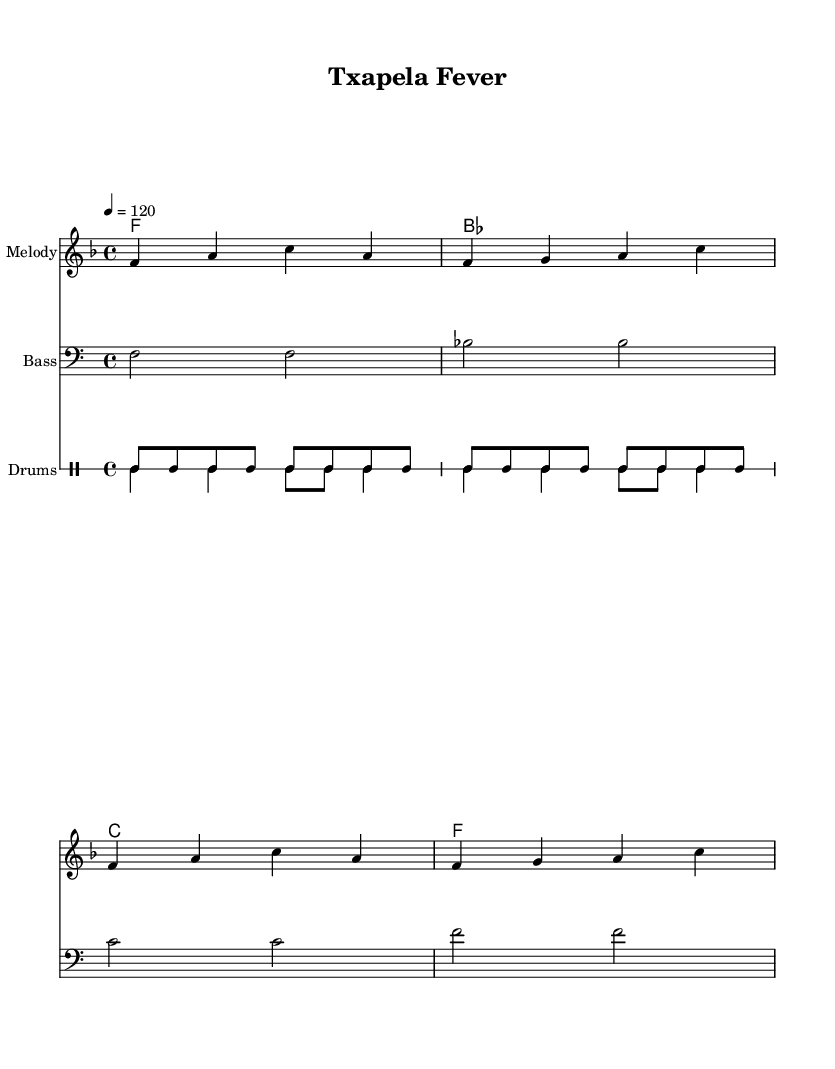What is the key signature of this music? The key signature is F major, which has one flat (B flat). You can determine this by looking at the key signature symbol at the beginning of the music, which indicates the notes that are flat throughout the piece.
Answer: F major What is the time signature of this music? The time signature is 4/4, which is indicated at the beginning of the sheet music by the fraction showing 4 beats per measure and a quarter note representing one beat.
Answer: 4/4 What is the tempo marking in this music? The tempo marking indicates the speed of the music; here, it is marked as 120 beats per minute. This is shown at the start of the piece with the notation "4 = 120," indicating the beats per measure and their corresponding speed.
Answer: 120 How many measures are in the melody? There are four measures in the melody section, as counted by the vertical barlines that separate each measure. This can be visually confirmed by dividing the melody into distinct segments marked by barlines.
Answer: 4 What type of music is this piece classified as? This piece is classified as Disco music, as indicated by the upbeat rhythms and lively tempo designed for dancing. In addition, the overall structure and instrumentation (e.g., bass, drums) are characteristic of Disco music styles popular in the 1970s.
Answer: Disco What instruments are featured in this score? The score features three distinct parts: Melody, Bass, and Drums. Each part is represented on separate staves, allowing for clear visibility of the musical lines for each instrument.
Answer: Melody, Bass, Drums What is the main rhythmic characteristic of this Disco piece? The main rhythmic characteristic is the upbeat, consistent groove provided by the bass and drums, designed to encourage dancing. The steady eighth notes in the drum patterns contribute to the infectious dance rhythm typical of Disco music.
Answer: Upbeat groove 